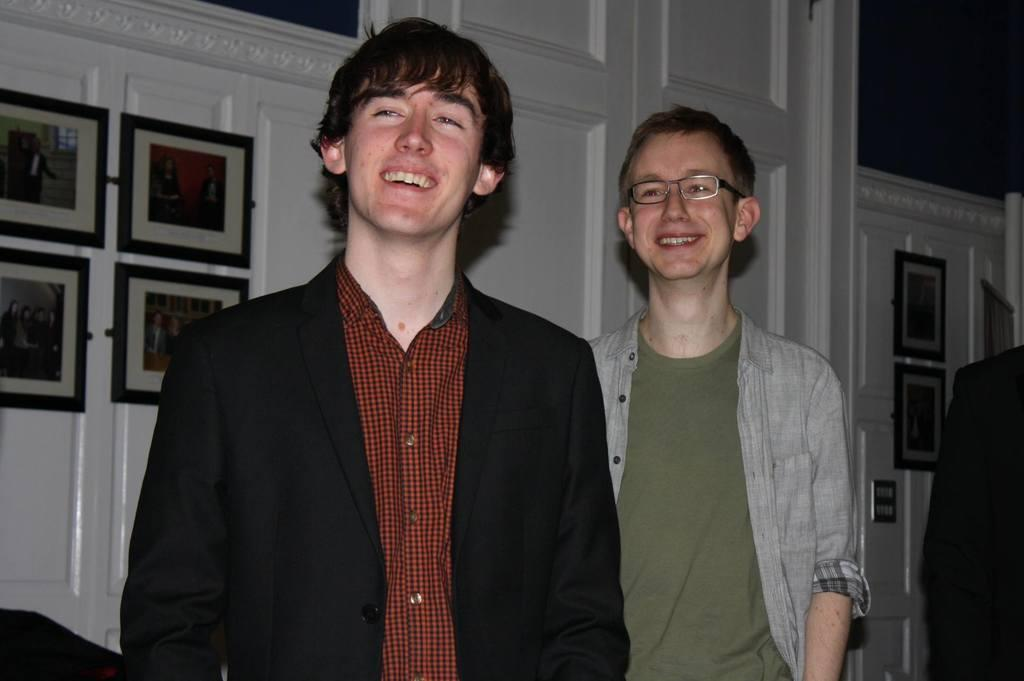How many people are present in the image? There are two people standing in the image. What can be seen on the wall in the image? There are frames on the wall in the image. What type of chalk is being used by the people in the image? There is no chalk present in the image. What is the harmony like between the two people in the image? The harmony between the two people cannot be determined from the image alone, as it only shows their physical presence and not their interactions or emotions. 